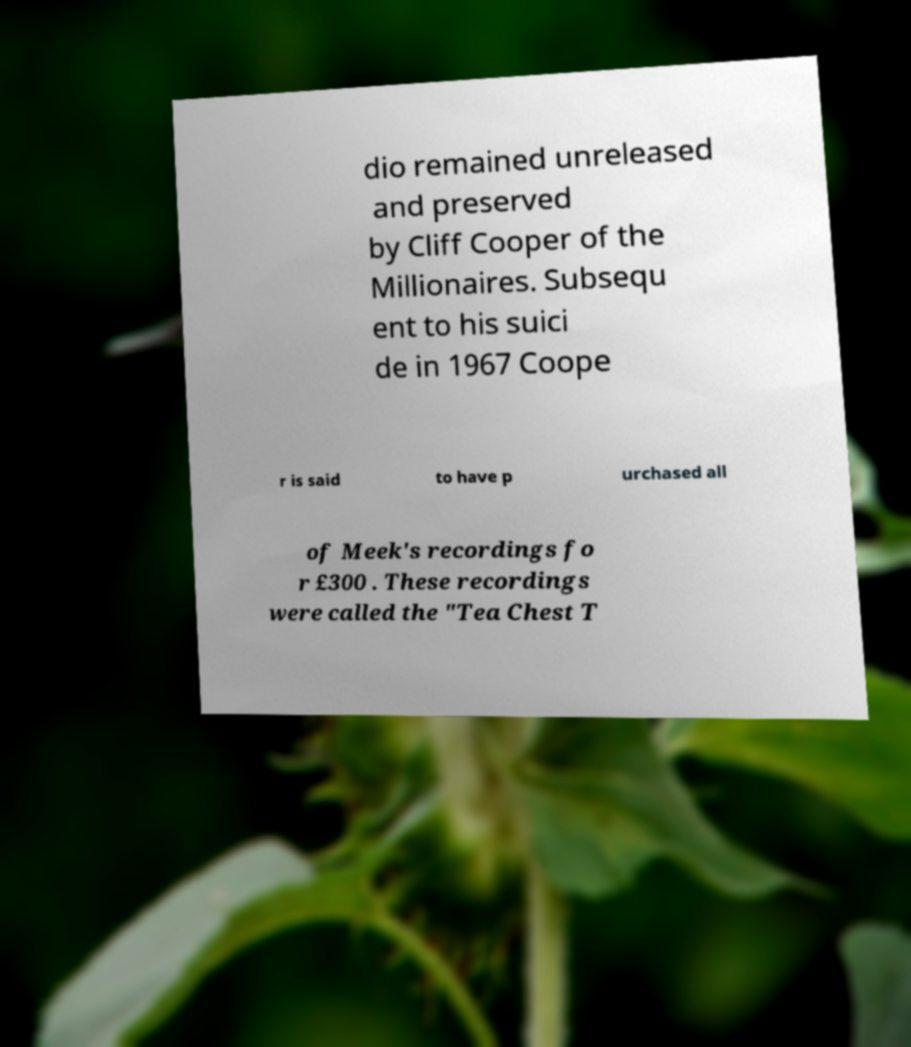I need the written content from this picture converted into text. Can you do that? dio remained unreleased and preserved by Cliff Cooper of the Millionaires. Subsequ ent to his suici de in 1967 Coope r is said to have p urchased all of Meek's recordings fo r £300 . These recordings were called the "Tea Chest T 